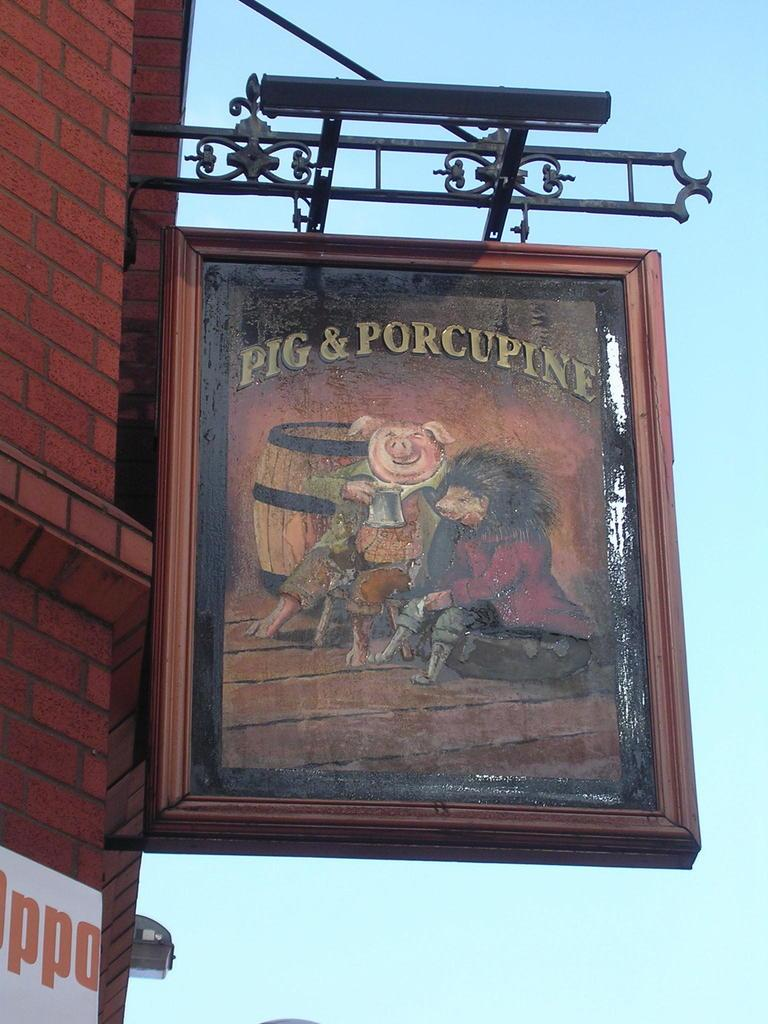Provide a one-sentence caption for the provided image. a sign that has the word pig on it. 